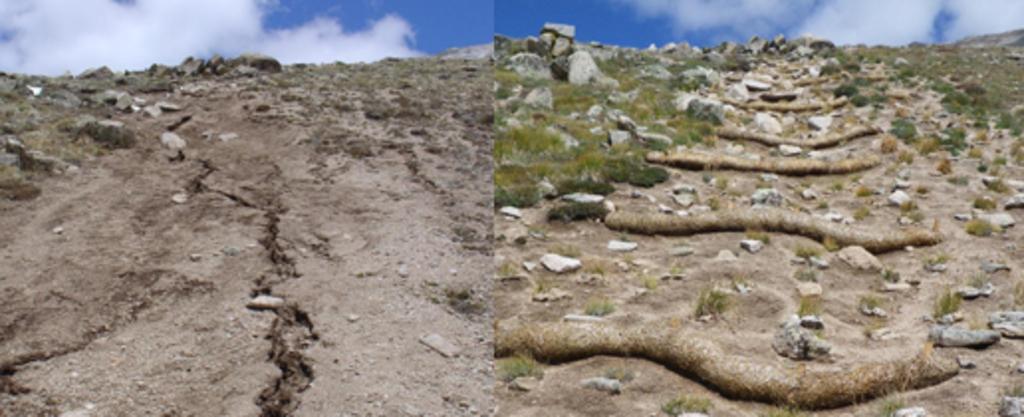Could you give a brief overview of what you see in this image? This is an edited picture. This picture has two parts. On the left part of the picture, we see sand stones and dried grass. We even see the sky and clouds. On the right part of the picture, we see grass, stones and sand. We even see the sky and clouds. 